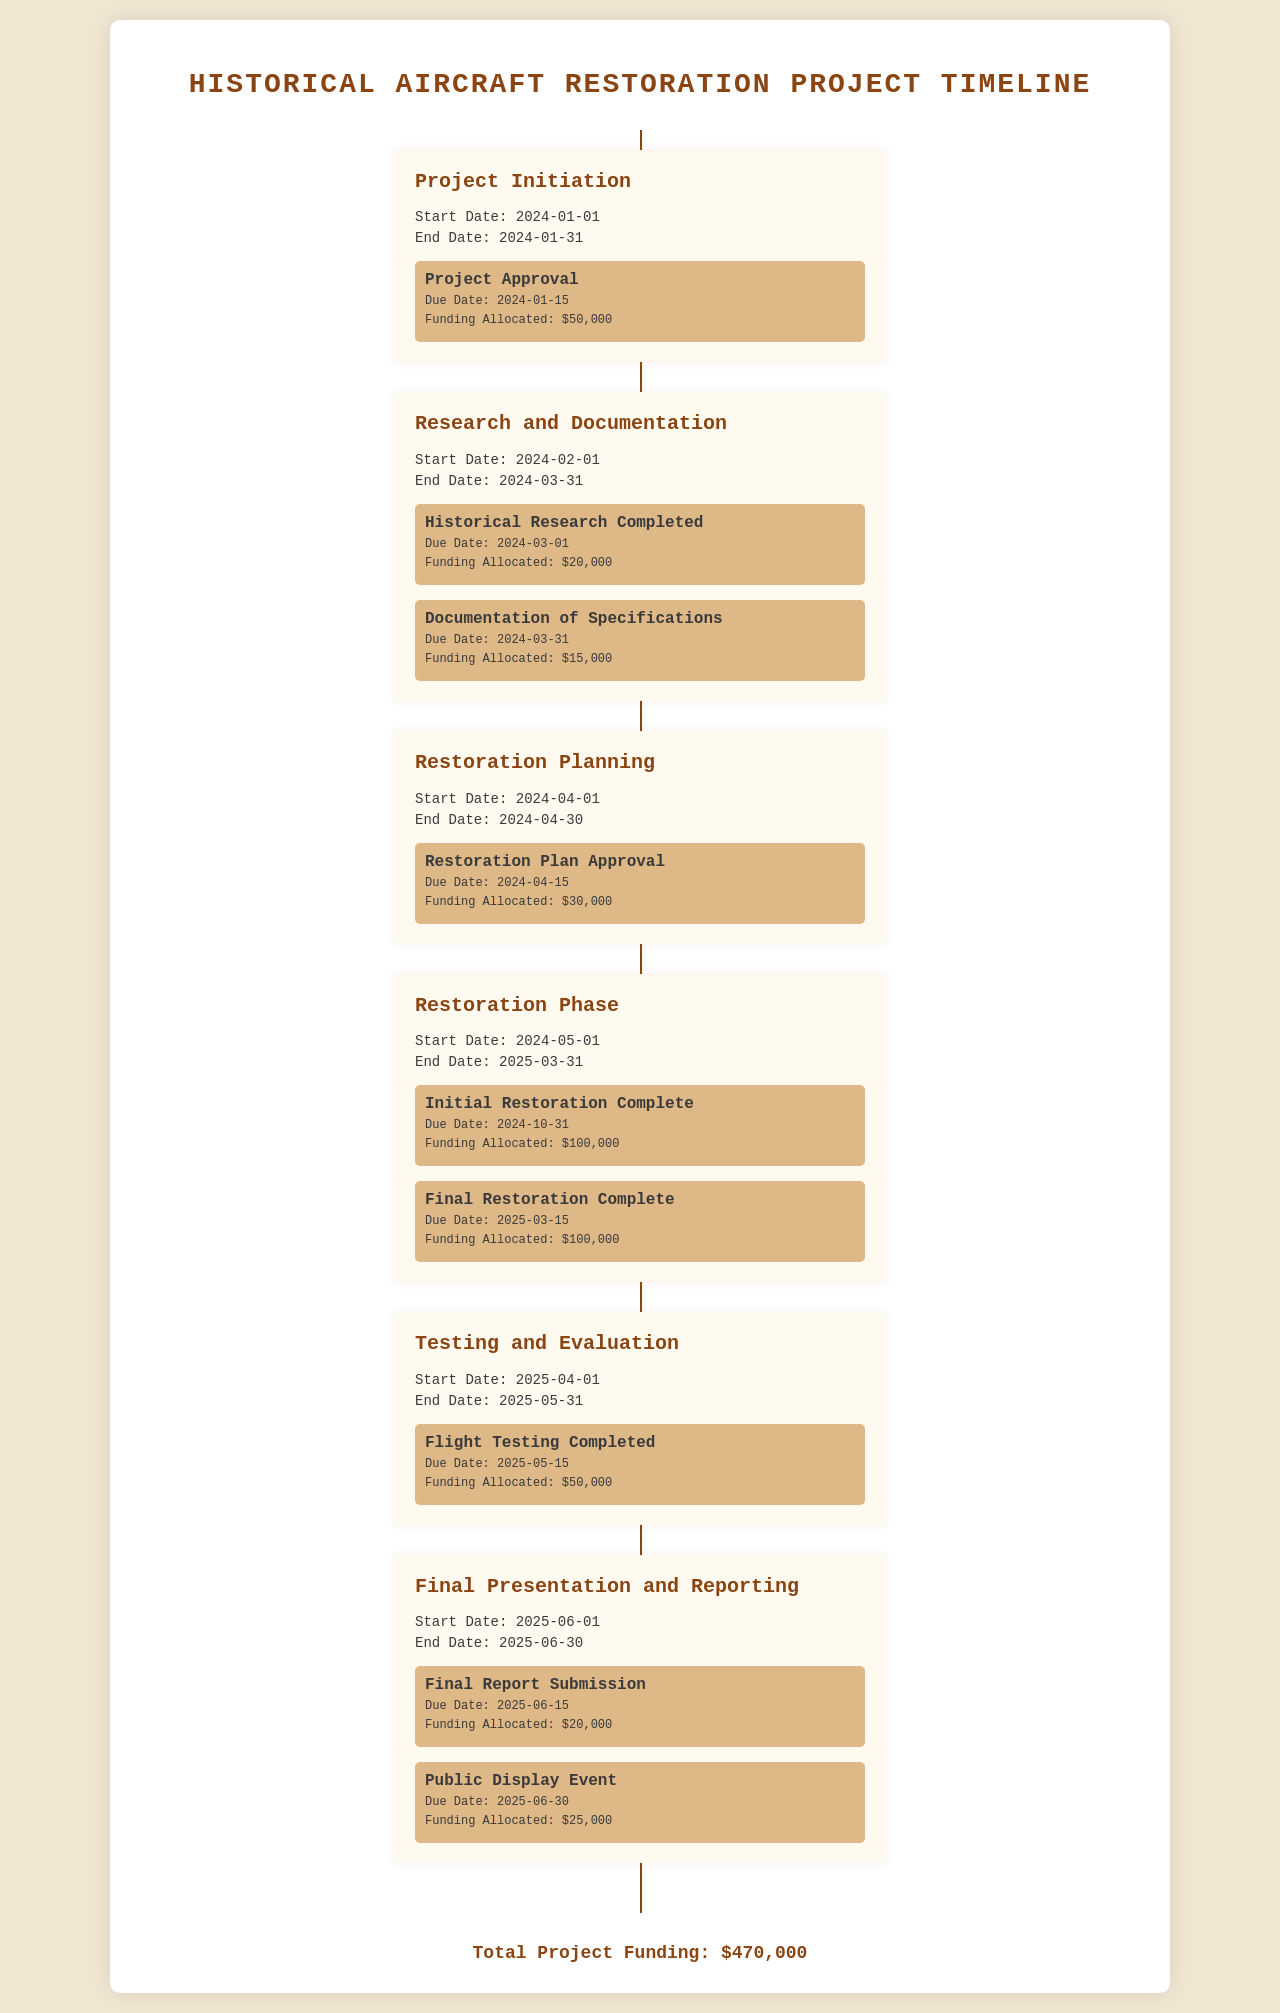What is the total project funding? The total project funding is listed at the end of the document, which summarizes the total financial resources allocated to the project.
Answer: $470,000 What is the start date of the Restoration Phase? The start date for the Restoration Phase is provided in the timeline section of the document.
Answer: 2024-05-01 What is the due date for the Public Display Event? The due date for the Public Display Event is specified under the Final Presentation and Reporting phase.
Answer: 2025-06-30 How much funding is allocated for the Initial Restoration Complete milestone? The funding allocated is detailed next to each milestone in the Restoration Phase.
Answer: $100,000 What is the end date of the Research and Documentation phase? The end date for the Research and Documentation phase is included in the timeline of events.
Answer: 2024-03-31 How many milestones are there in the Restoration Phase? The document lists the milestones under each phase, with a count provided for the Restoration Phase.
Answer: 2 What is the title of the last phase in the timeline? The title of the last phase can be found at the beginning of the Final Presentation and Reporting section.
Answer: Final Presentation and Reporting When is the due date for the Flight Testing Completed milestone? The due date is mentioned in the Testing and Evaluation phase details.
Answer: 2025-05-15 